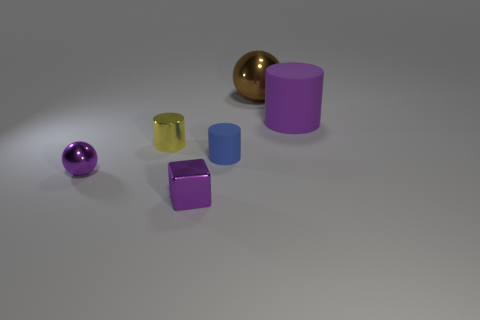What number of blue objects are either matte cylinders or big cylinders?
Your answer should be very brief. 1. There is a purple object that is behind the tiny sphere; is its shape the same as the tiny matte object?
Give a very brief answer. Yes. Is the number of cylinders that are in front of the big purple thing greater than the number of small metal cubes?
Your answer should be very brief. Yes. How many purple rubber objects have the same size as the purple metal sphere?
Keep it short and to the point. 0. What size is the metal sphere that is the same color as the big matte object?
Provide a short and direct response. Small. How many things are brown metallic objects or things on the left side of the big brown sphere?
Your response must be concise. 5. There is a shiny thing that is both on the right side of the small ball and left of the purple cube; what color is it?
Keep it short and to the point. Yellow. Is the size of the brown sphere the same as the purple cylinder?
Offer a terse response. Yes. There is a sphere that is to the left of the large brown object; what is its color?
Ensure brevity in your answer.  Purple. Is there a shiny ball of the same color as the cube?
Your answer should be very brief. Yes. 